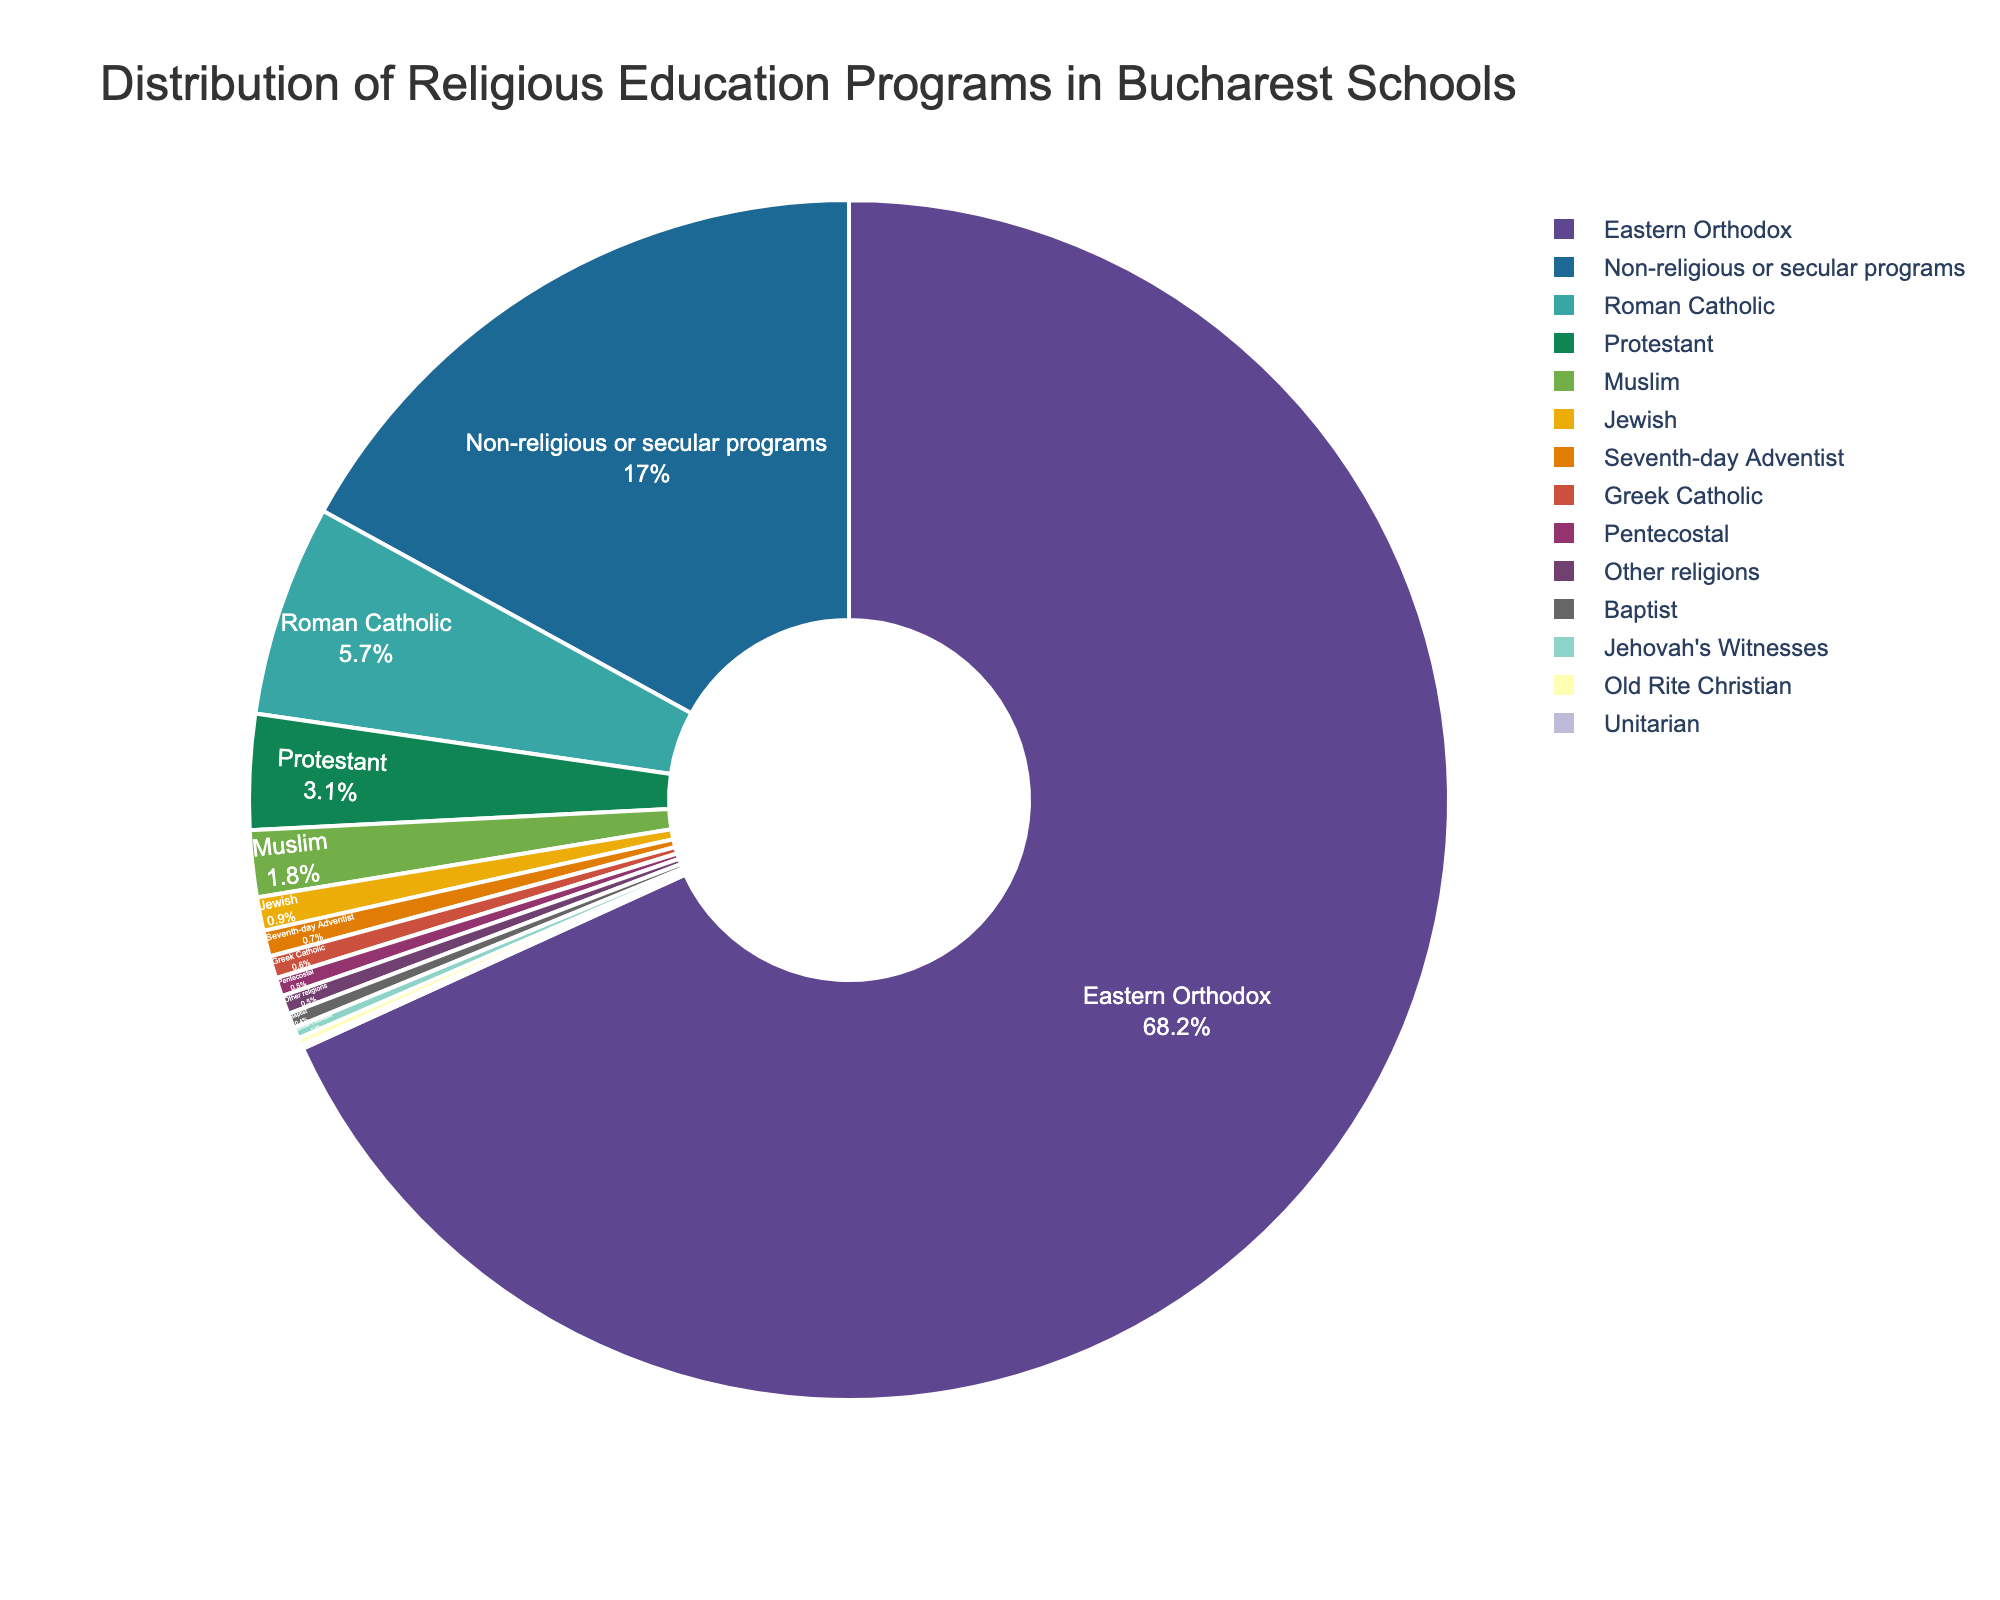What is the faith tradition with the largest percentage of religious education programs in Bucharest schools? The faith tradition with the largest percentage is identified by finding the slice with the highest value in the pie chart. The largest percentage shown is 68.2%, which corresponds to Eastern Orthodox.
Answer: Eastern Orthodox Which faith tradition has a lower percentage of religious education programs: Protestant or Muslim? To determine which has a lower percentage, compare the slices representing Protestant and Muslim. Protestant has 3.1%, while Muslim has 1.8%.
Answer: Muslim What is the combined percentage of Roman Catholic, Protestant, and Seventh-day Adventist education programs? To find the combined percentage, sum the values for Roman Catholic (5.7%), Protestant (3.1%), and Seventh-day Adventist (0.7%). The sum is 5.7 + 3.1 + 0.7.
Answer: 9.5% How much larger is the percentage of Eastern Orthodox programs compared to Roman Catholic programs? Subtract the Roman Catholic percentage (5.7%) from the Eastern Orthodox percentage (68.2%). The difference is 68.2 - 5.7.
Answer: 62.5% What is the percentage of education programs categorized as non-religious or secular? Find the slice labeled "Non-religious or secular programs" in the pie chart. The label shows 17%.
Answer: 17% Which faith traditions have a percentage lower than 1%? Identify the slices with percentages lower than 1%. These slices are Jewish (0.9%), Seventh-day Adventist (0.7%), Greek Catholic (0.6%), Pentecostal (0.5%), Baptist (0.4%), Jehovah's Witnesses (0.3%), Old Rite Christian (0.2%), Unitarian (0.1%), and Other religions (0.5%).
Answer: Jewish, Seventh-day Adventist, Greek Catholic, Pentecostal, Baptist, Jehovah's Witnesses, Old Rite Christian, Unitarian, Other religions By how much does the percentage of non-religious or secular programs exceed the combined percentage of Jewish, Greek Catholic, and Unitarian programs? First, sum the percentages of Jewish (0.9%), Greek Catholic (0.6%), and Unitarian (0.1%). Sum is 0.9 + 0.6 + 0.1 = 1.6%. Then subtract this sum from the percentage of non-religious or secular programs (17%). Difference is 17 - 1.6.
Answer: 15.4% What is the average percentage of religious education programs for the following faith traditions: Baptist, Pentecostal, and Jehovah's Witnesses? To find the average, sum the percentages of Baptist (0.4%), Pentecostal (0.5%), and Jehovah's Witnesses (0.3%). The sum is 0.4 + 0.5 + 0.3 = 1.2%. Then divide by 3 (the number of faith traditions). The average is 1.2 / 3.
Answer: 0.4% Which faith tradition has a percentage closest to that of Old Rite Christian programs? Compare the 0.2% of Old Rite Christian programs to other percentages. Greek Catholic has 0.6%, which is farther, and Unitarian has 0.1%, which is closest.
Answer: Unitarian Is the percentage of Protestant programs higher or lower than the average percentage of non-religious or secular programs and Old Rite Christian programs combined? Calculate the average of non-religious or secular programs (17%) and Old Rite Christian programs (0.2%). Average is (17 + 0.2) / 2 = 8.6%. Compare 8.6% to Protestant (3.1%).
Answer: Lower 